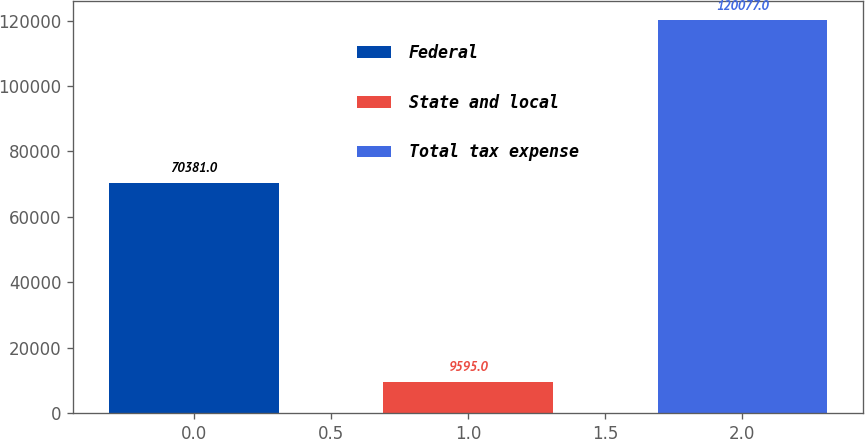<chart> <loc_0><loc_0><loc_500><loc_500><bar_chart><fcel>Federal<fcel>State and local<fcel>Total tax expense<nl><fcel>70381<fcel>9595<fcel>120077<nl></chart> 